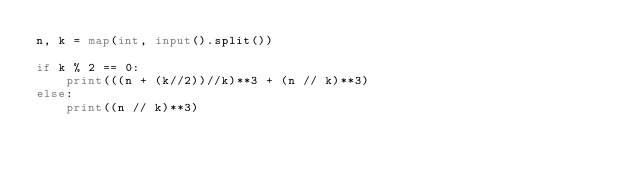Convert code to text. <code><loc_0><loc_0><loc_500><loc_500><_Python_>n, k = map(int, input().split())

if k % 2 == 0:
    print(((n + (k//2))//k)**3 + (n // k)**3)
else:
    print((n // k)**3)</code> 